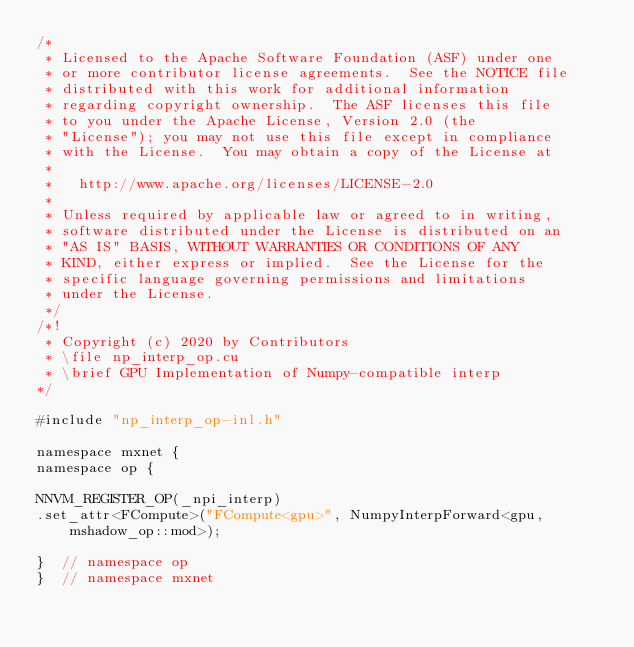Convert code to text. <code><loc_0><loc_0><loc_500><loc_500><_Cuda_>/*
 * Licensed to the Apache Software Foundation (ASF) under one
 * or more contributor license agreements.  See the NOTICE file
 * distributed with this work for additional information
 * regarding copyright ownership.  The ASF licenses this file
 * to you under the Apache License, Version 2.0 (the
 * "License"); you may not use this file except in compliance
 * with the License.  You may obtain a copy of the License at
 *
 *   http://www.apache.org/licenses/LICENSE-2.0
 *
 * Unless required by applicable law or agreed to in writing,
 * software distributed under the License is distributed on an
 * "AS IS" BASIS, WITHOUT WARRANTIES OR CONDITIONS OF ANY
 * KIND, either express or implied.  See the License for the
 * specific language governing permissions and limitations
 * under the License.
 */
/*!
 * Copyright (c) 2020 by Contributors
 * \file np_interp_op.cu
 * \brief GPU Implementation of Numpy-compatible interp
*/

#include "np_interp_op-inl.h"

namespace mxnet {
namespace op {

NNVM_REGISTER_OP(_npi_interp)
.set_attr<FCompute>("FCompute<gpu>", NumpyInterpForward<gpu, mshadow_op::mod>);

}  // namespace op
}  // namespace mxnet
</code> 